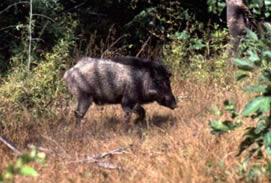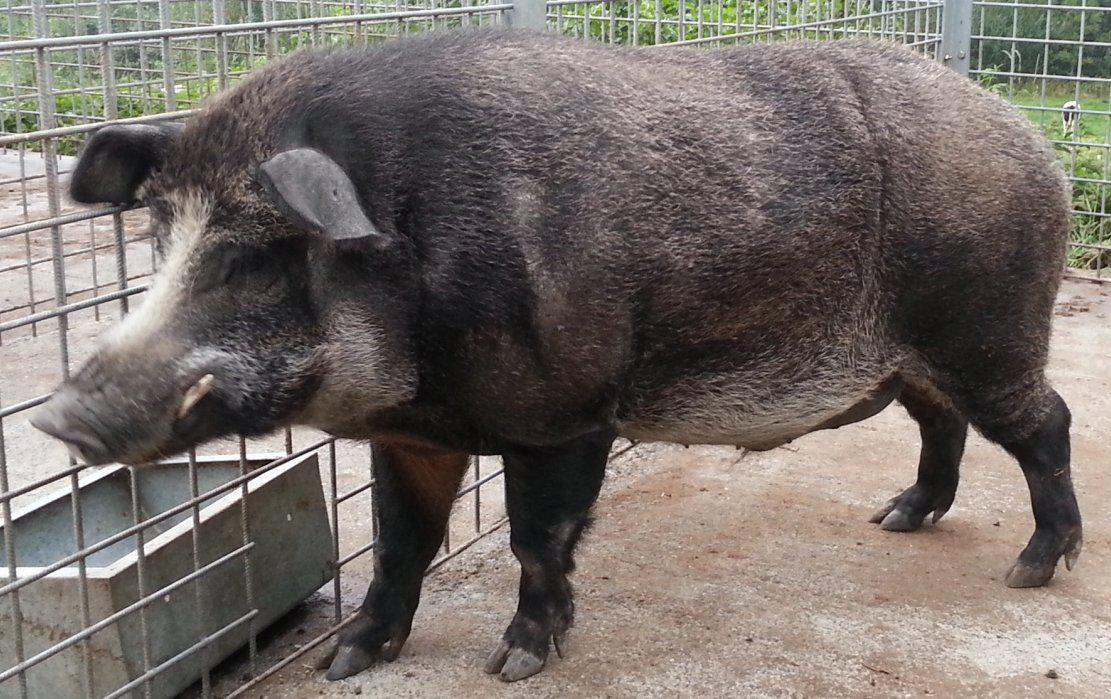The first image is the image on the left, the second image is the image on the right. Analyze the images presented: Is the assertion "Both animals are standing in a field." valid? Answer yes or no. No. The first image is the image on the left, the second image is the image on the right. Considering the images on both sides, is "The boar in the right image is standing in green foliage." valid? Answer yes or no. No. 